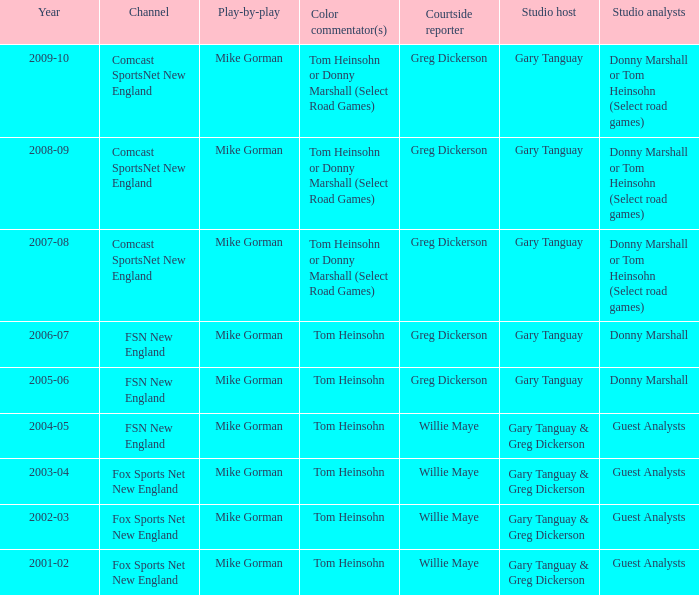Who is the studio host for the year 2006-07? Gary Tanguay. 